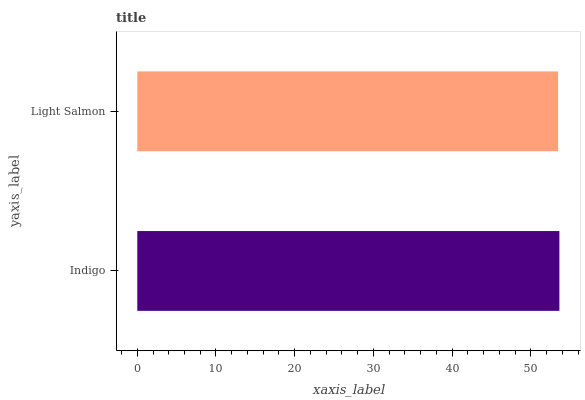Is Light Salmon the minimum?
Answer yes or no. Yes. Is Indigo the maximum?
Answer yes or no. Yes. Is Light Salmon the maximum?
Answer yes or no. No. Is Indigo greater than Light Salmon?
Answer yes or no. Yes. Is Light Salmon less than Indigo?
Answer yes or no. Yes. Is Light Salmon greater than Indigo?
Answer yes or no. No. Is Indigo less than Light Salmon?
Answer yes or no. No. Is Indigo the high median?
Answer yes or no. Yes. Is Light Salmon the low median?
Answer yes or no. Yes. Is Light Salmon the high median?
Answer yes or no. No. Is Indigo the low median?
Answer yes or no. No. 